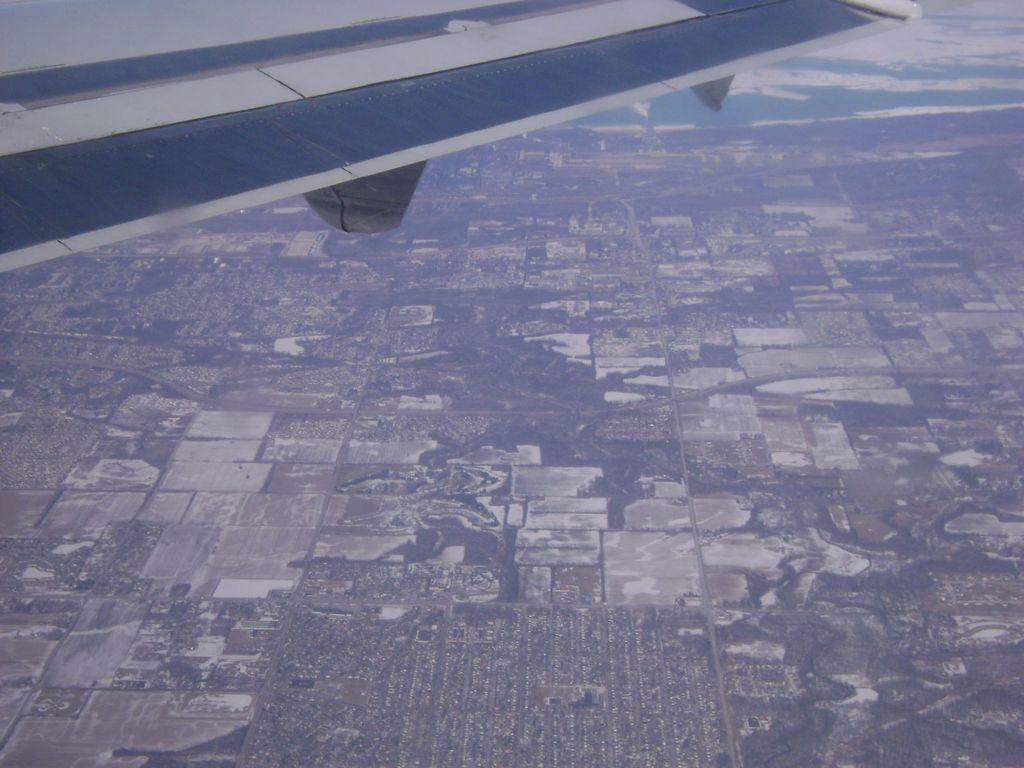What type of view is depicted in the image? The image is an aerial view. What can be seen in the aerial view? There is a wing of an airplane visible in the image. What is the work route of the chain in the image? There is no chain or work route present in the image; it only features an aerial view of an airplane wing. 